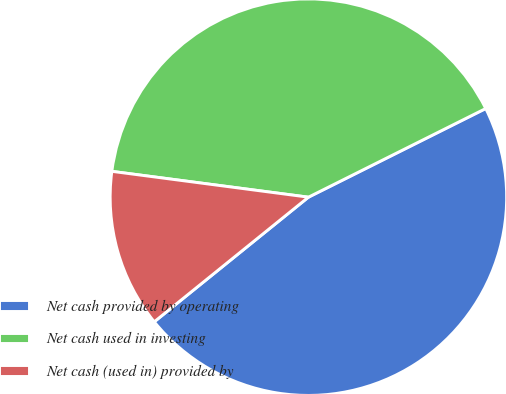Convert chart to OTSL. <chart><loc_0><loc_0><loc_500><loc_500><pie_chart><fcel>Net cash provided by operating<fcel>Net cash used in investing<fcel>Net cash (used in) provided by<nl><fcel>46.56%<fcel>40.54%<fcel>12.9%<nl></chart> 